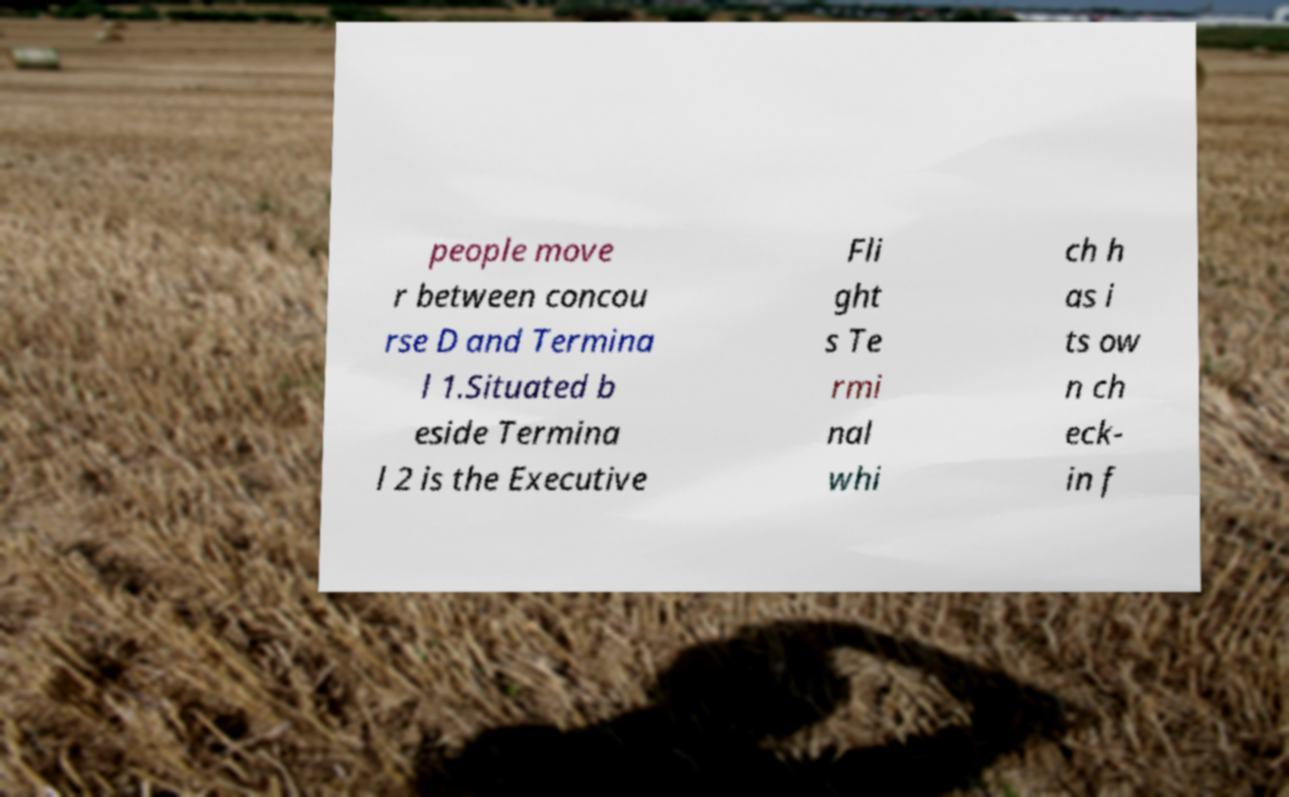Please read and relay the text visible in this image. What does it say? people move r between concou rse D and Termina l 1.Situated b eside Termina l 2 is the Executive Fli ght s Te rmi nal whi ch h as i ts ow n ch eck- in f 